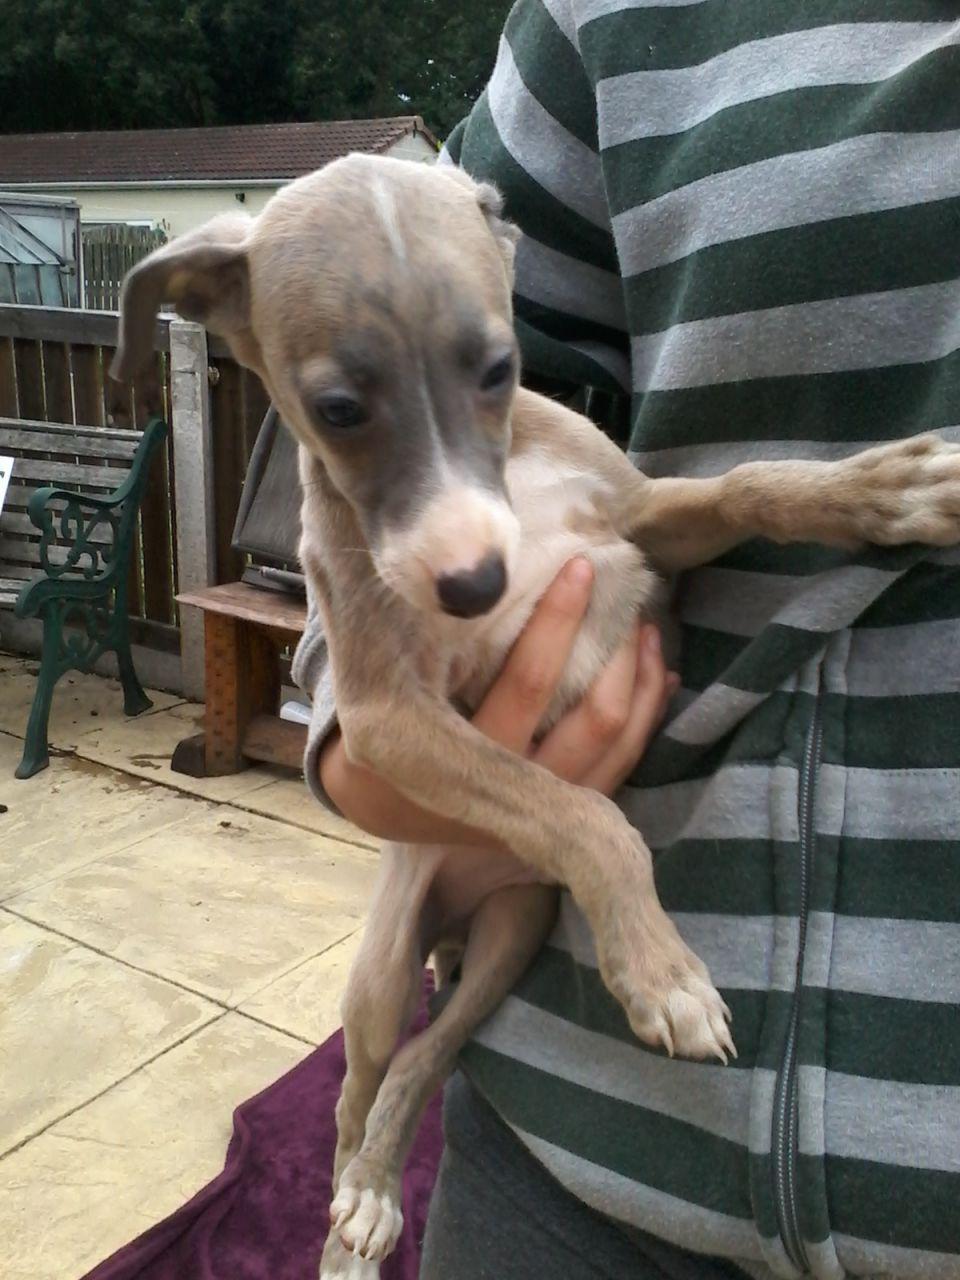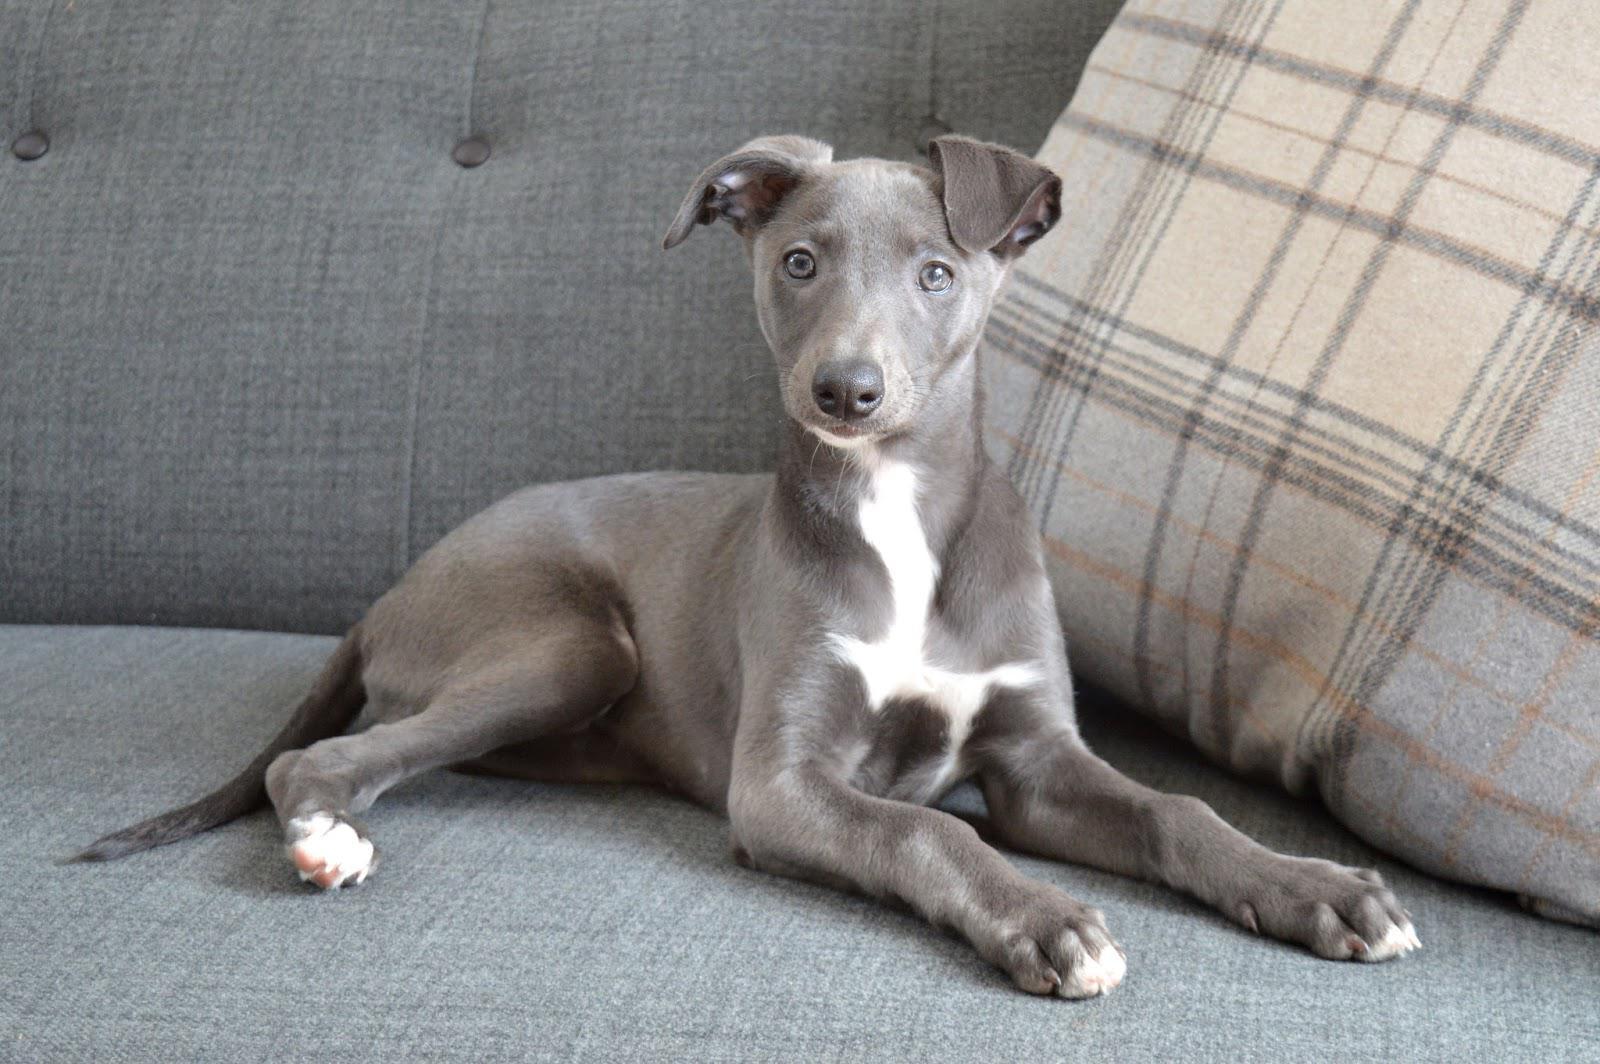The first image is the image on the left, the second image is the image on the right. Assess this claim about the two images: "There are more dogs in the right image than in the left.". Correct or not? Answer yes or no. No. The first image is the image on the left, the second image is the image on the right. Considering the images on both sides, is "In one image, a dog is being cradled in a person's arm." valid? Answer yes or no. Yes. 